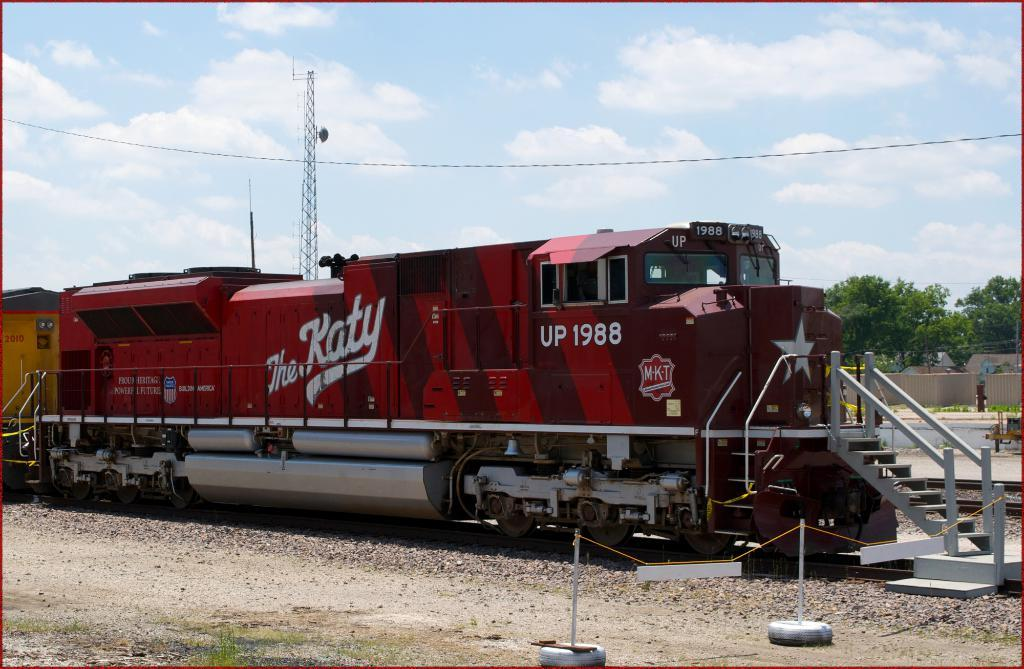What mode of transportation can be seen on the ground in the image? There is a train on the ground in the image. What architectural feature is present in the image? There are stairs in the image. What type of structure can be seen in the image? There are poles in the image. What type of material can be seen in the image? There are threads in the image. What type of buildings can be seen in the image? There are houses in the image. What type of vegetation can be seen in the image? There are trees in the image. What type of barrier can be seen in the image? There is a fence in the image. What type of communication device can be seen in the image? There is an antenna in the image. What part of the natural environment is visible in the image? The sky is visible in the image. What type of sweater is being worn by the train in the image? There is no sweater present in the image, as the subject is a train and not a person. 